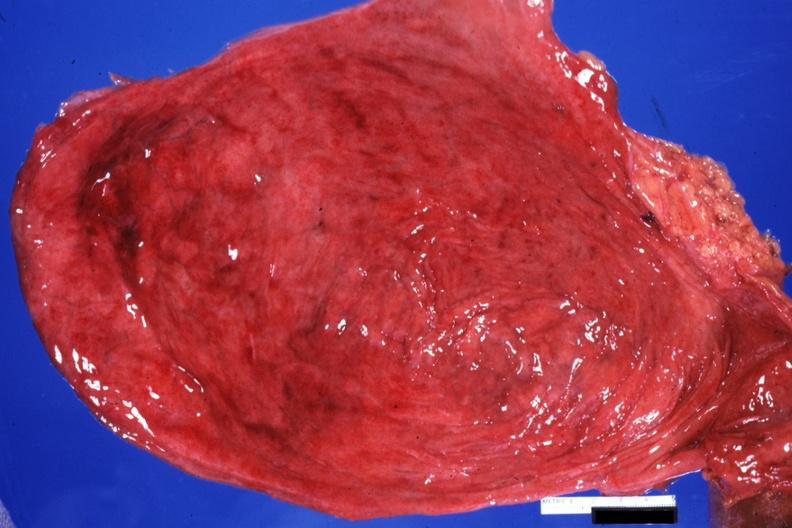s bladder present?
Answer the question using a single word or phrase. Yes 